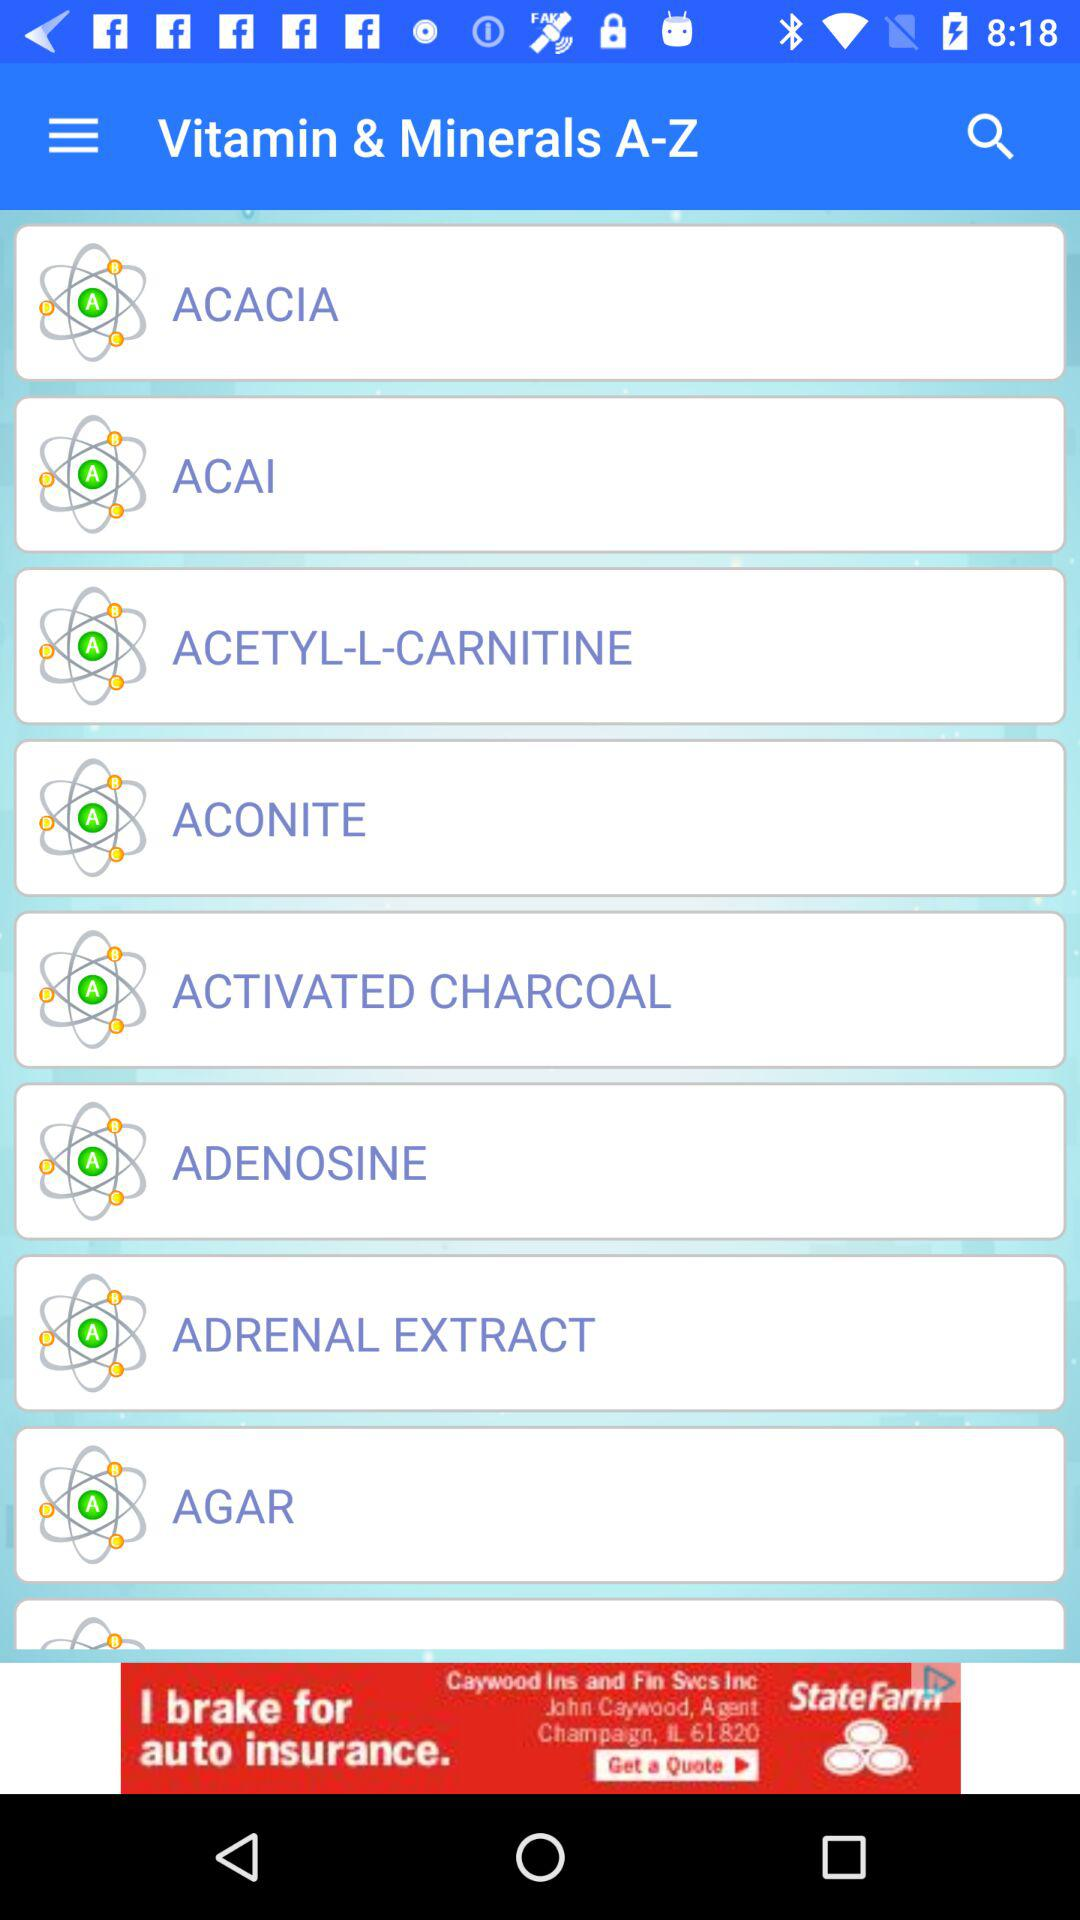What is the application name? The application name is "Vitamin & Minerals A-Z". 